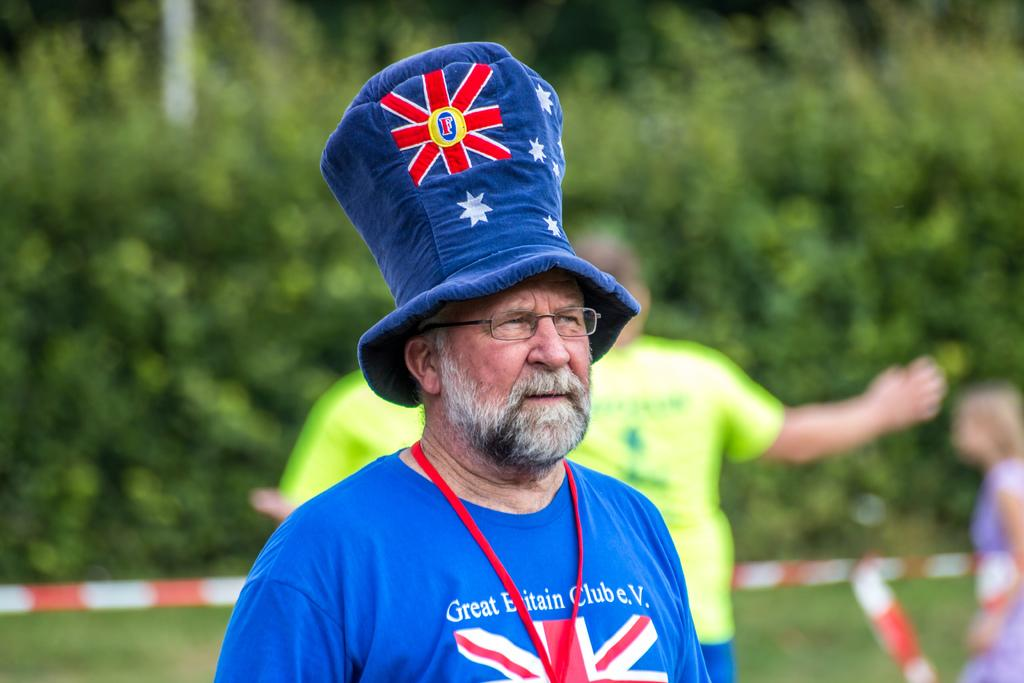Provide a one-sentence caption for the provided image. A middle-age man wears a tall hat and a t-shirt for the Great Britain Club. 